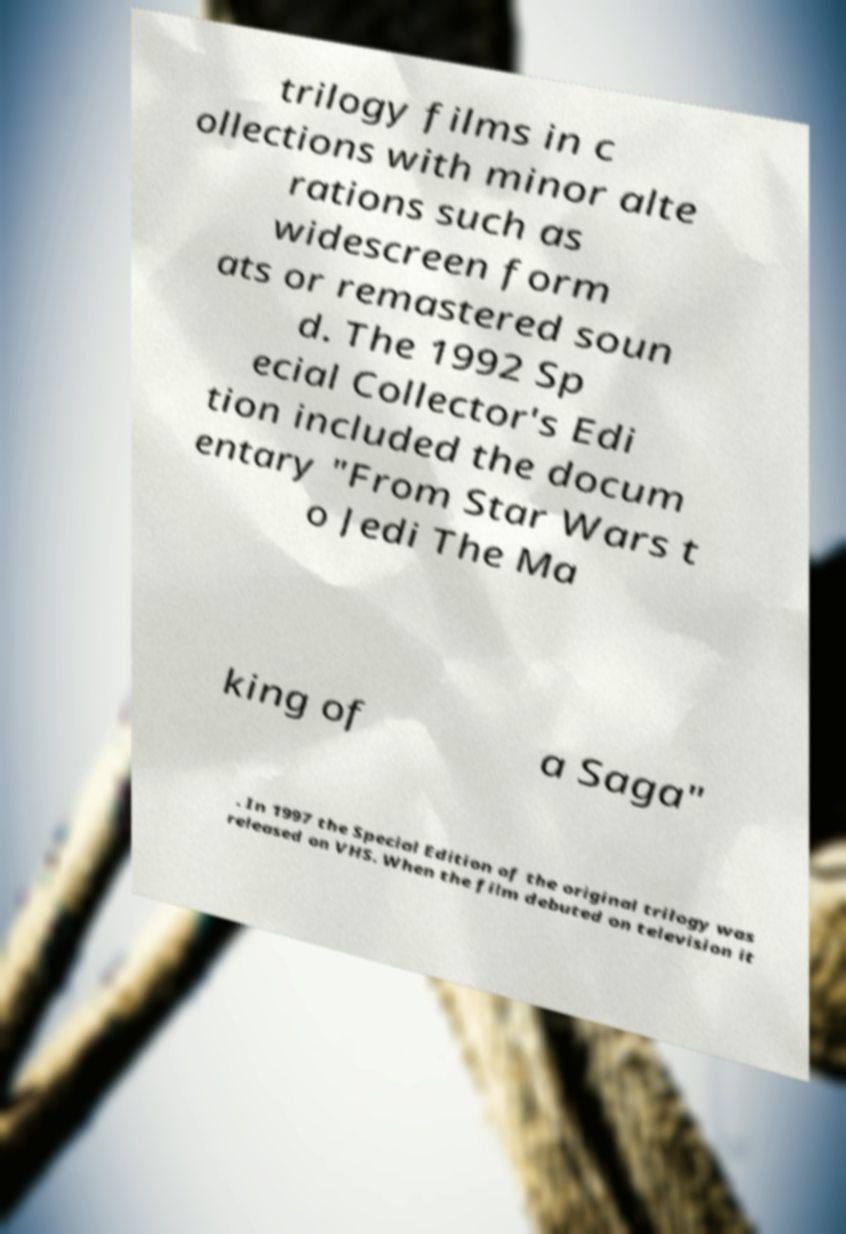Could you assist in decoding the text presented in this image and type it out clearly? trilogy films in c ollections with minor alte rations such as widescreen form ats or remastered soun d. The 1992 Sp ecial Collector's Edi tion included the docum entary "From Star Wars t o Jedi The Ma king of a Saga" . In 1997 the Special Edition of the original trilogy was released on VHS. When the film debuted on television it 